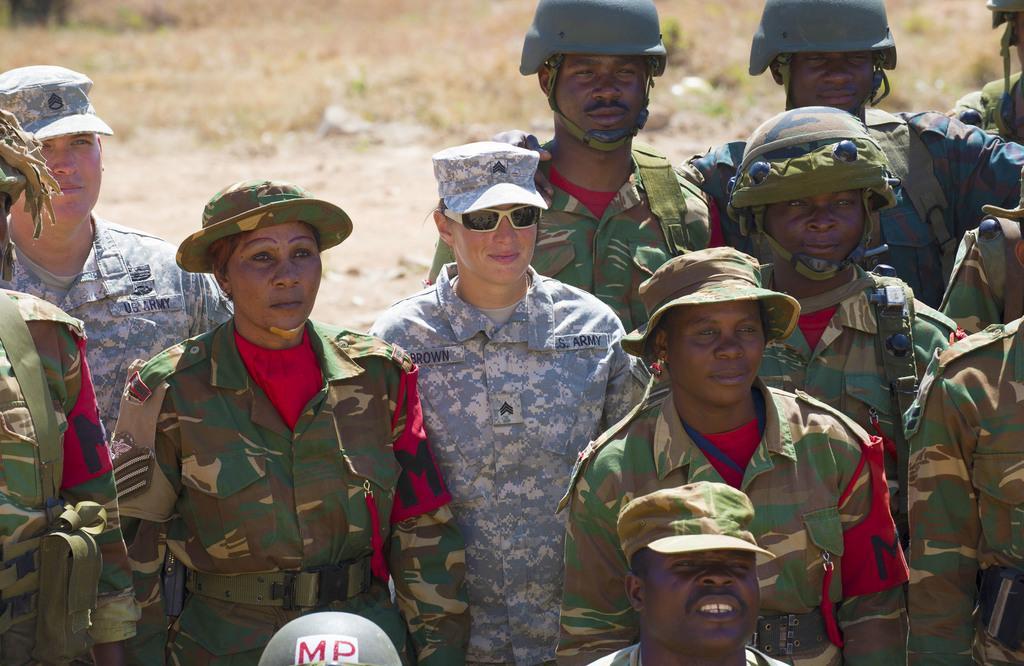How would you summarize this image in a sentence or two? In this image I can see a group of people are standing, they are wearing dresses and caps. 